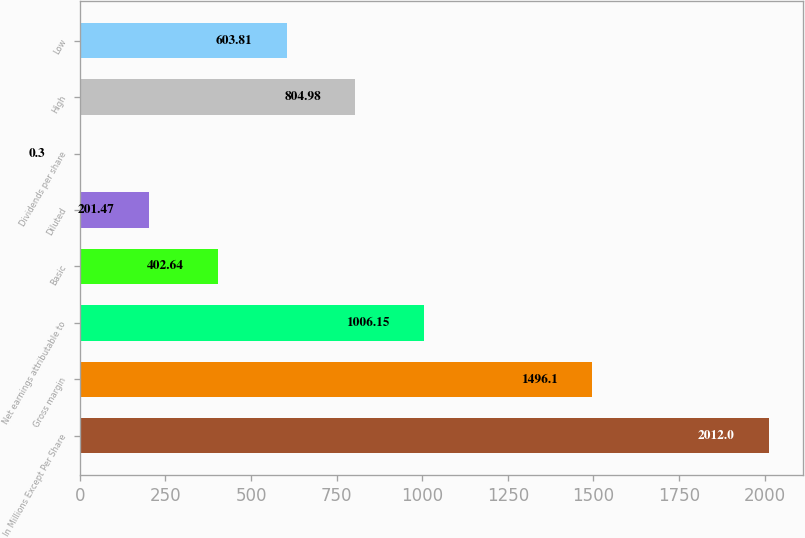Convert chart to OTSL. <chart><loc_0><loc_0><loc_500><loc_500><bar_chart><fcel>In Millions Except Per Share<fcel>Gross margin<fcel>Net earnings attributable to<fcel>Basic<fcel>Diluted<fcel>Dividends per share<fcel>High<fcel>Low<nl><fcel>2012<fcel>1496.1<fcel>1006.15<fcel>402.64<fcel>201.47<fcel>0.3<fcel>804.98<fcel>603.81<nl></chart> 